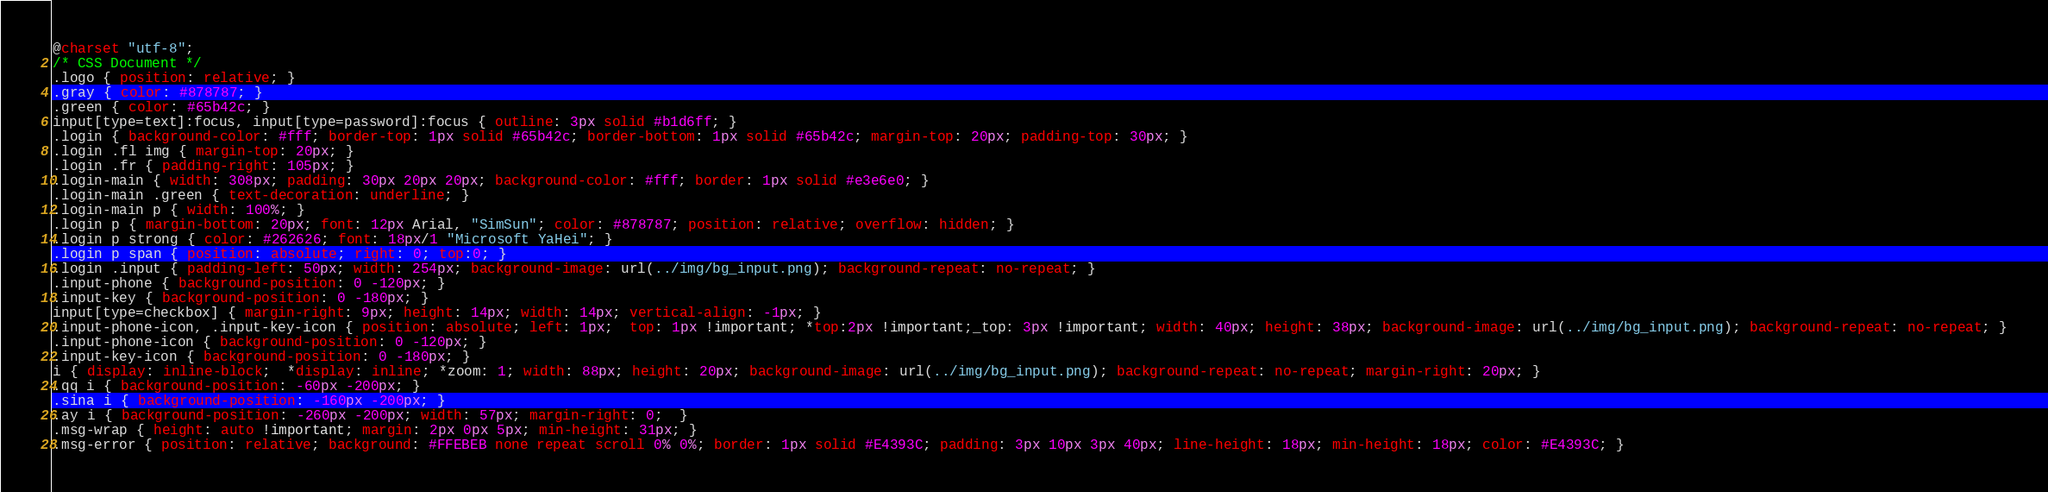Convert code to text. <code><loc_0><loc_0><loc_500><loc_500><_CSS_>@charset "utf-8";
/* CSS Document */
.logo { position: relative; }
.gray { color: #878787; }
.green { color: #65b42c; }
input[type=text]:focus, input[type=password]:focus { outline: 3px solid #b1d6ff; }
.login { background-color: #fff; border-top: 1px solid #65b42c; border-bottom: 1px solid #65b42c; margin-top: 20px; padding-top: 30px; }
.login .fl img { margin-top: 20px; }
.login .fr { padding-right: 105px; }
.login-main { width: 308px; padding: 30px 20px 20px; background-color: #fff; border: 1px solid #e3e6e0; }
.login-main .green { text-decoration: underline; }
.login-main p { width: 100%; }
.login p { margin-bottom: 20px; font: 12px Arial, "SimSun"; color: #878787; position: relative; overflow: hidden; }
.login p strong { color: #262626; font: 18px/1 "Microsoft YaHei"; }
.login p span { position: absolute; right: 0; top:0; }
.login .input { padding-left: 50px; width: 254px; background-image: url(../img/bg_input.png); background-repeat: no-repeat; }
.input-phone { background-position: 0 -120px; }
.input-key { background-position: 0 -180px; }
input[type=checkbox] { margin-right: 9px; height: 14px; width: 14px; vertical-align: -1px; }
.input-phone-icon, .input-key-icon { position: absolute; left: 1px;  top: 1px !important; *top:2px !important;_top: 3px !important; width: 40px; height: 38px; background-image: url(../img/bg_input.png); background-repeat: no-repeat; }
.input-phone-icon { background-position: 0 -120px; }
.input-key-icon { background-position: 0 -180px; }
i { display: inline-block;  *display: inline; *zoom: 1; width: 88px; height: 20px; background-image: url(../img/bg_input.png); background-repeat: no-repeat; margin-right: 20px; }
.qq i { background-position: -60px -200px; }
.sina i { background-position: -160px -200px; }
.ay i { background-position: -260px -200px; width: 57px; margin-right: 0;  }
.msg-wrap { height: auto !important; margin: 2px 0px 5px; min-height: 31px; }
.msg-error { position: relative; background: #FFEBEB none repeat scroll 0% 0%; border: 1px solid #E4393C; padding: 3px 10px 3px 40px; line-height: 18px; min-height: 18px; color: #E4393C; }

</code> 